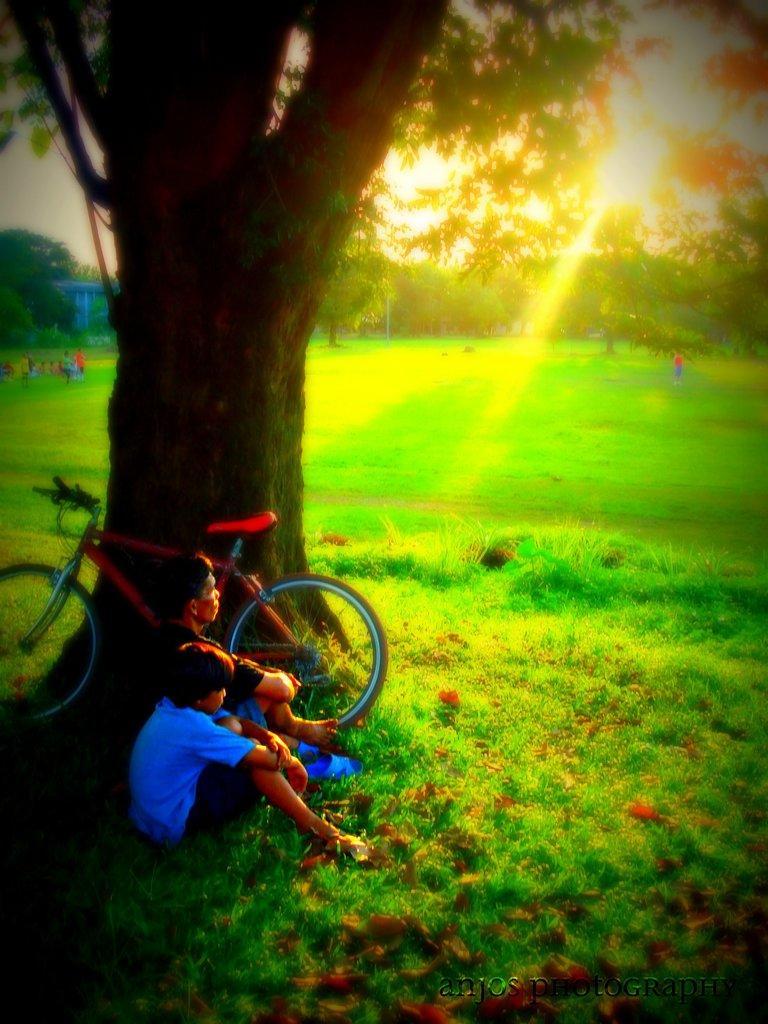Please provide a concise description of this image. In this image, we can see two persons are sitting on the grass. Here we can see a bicycle and trees. Background we can see few people, trees, grass, pole and sky. On the right side bottom corner, there is a watermark in the image. 